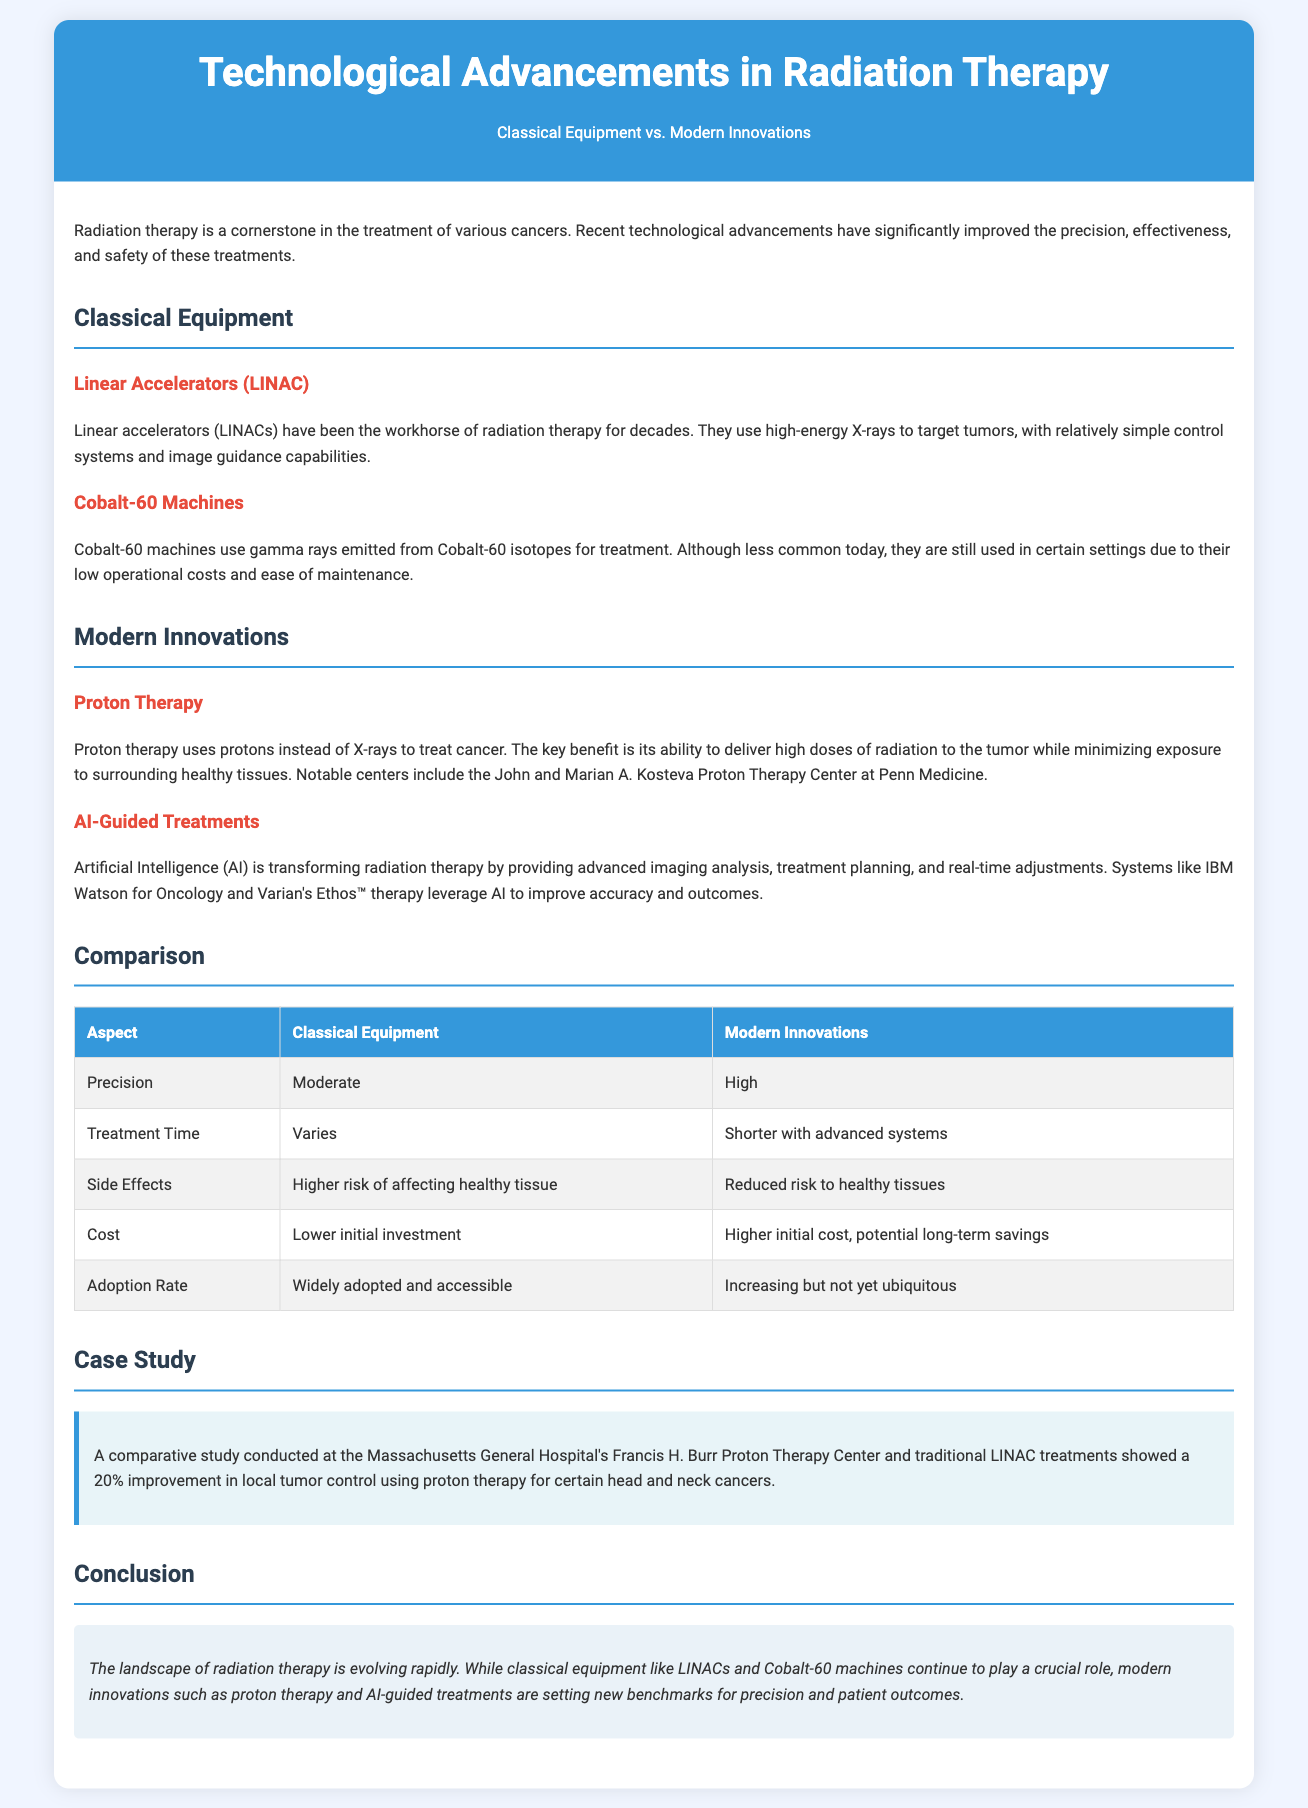What are the two types of classical equipment discussed? The document mentions Linear Accelerators (LINAC) and Cobalt-60 machines as the classical equipment used in radiation therapy.
Answer: Linear Accelerators (LINAC) and Cobalt-60 machines What is a key benefit of proton therapy? Proton therapy's key benefit is its ability to deliver high doses of radiation to the tumor while minimizing exposure to surrounding healthy tissues.
Answer: Minimizing exposure to healthy tissues What is the trend in the adoption rate of modern innovations? The document states that modern innovations are increasing but not yet ubiquitous, indicating their adoption rate is growing.
Answer: Increasing but not yet ubiquitous Which AI system is mentioned for enhancing radiation therapy? The document references IBM Watson for Oncology as one of the AI systems used in improving radiation therapy outcomes.
Answer: IBM Watson for Oncology What percentage improvement in local tumor control was reported in the case study? The comparative study highlighted a 20% improvement in local tumor control using proton therapy for certain head and neck cancers.
Answer: 20% What aspect of classical equipment has a lower initial investment? The comparison indicates that classical equipment has a lower initial investment compared to modern innovations which have a higher initial cost.
Answer: Lower initial investment What is the typical treatment time for modern innovations? Modern innovations allow for shorter treatment times with advanced systems, reducing the duration of therapy sessions.
Answer: Shorter with advanced systems How does precision compare between classical equipment and modern innovations? The comparison shows that classical equipment offers moderate precision, while modern innovations achieve high precision in treatment.
Answer: High What type of document is this infographic? The document is a comparison infographic that presents a visual comparison between classical equipment and modern innovations in radiation therapy.
Answer: Comparison infographic 